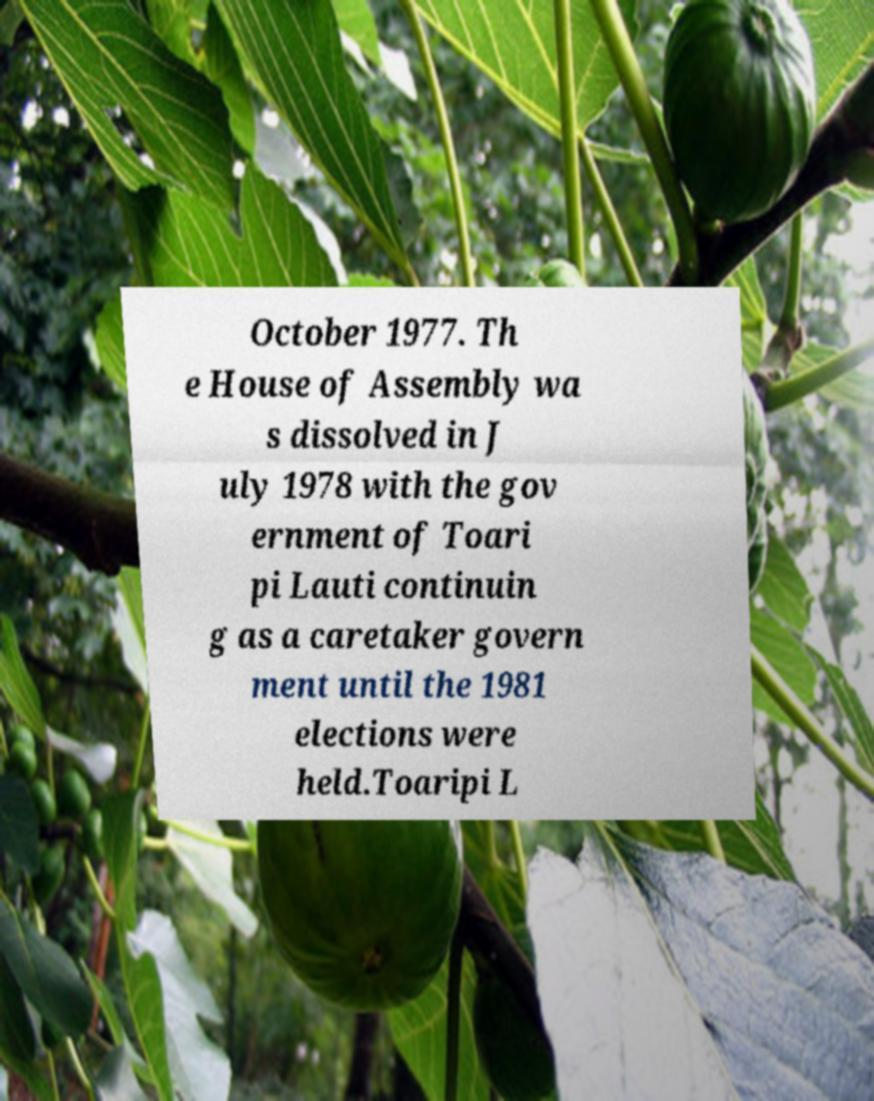Please identify and transcribe the text found in this image. October 1977. Th e House of Assembly wa s dissolved in J uly 1978 with the gov ernment of Toari pi Lauti continuin g as a caretaker govern ment until the 1981 elections were held.Toaripi L 